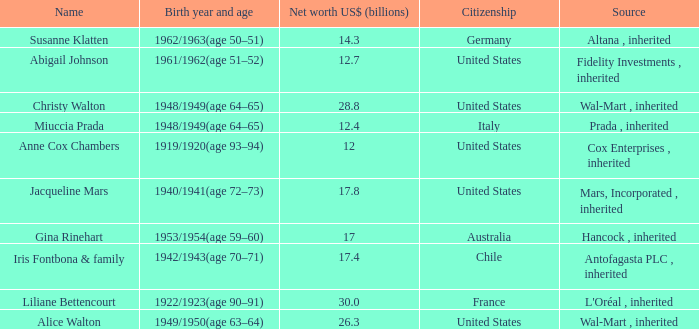What's the source of wealth of the person worth $17 billion? Hancock , inherited. 